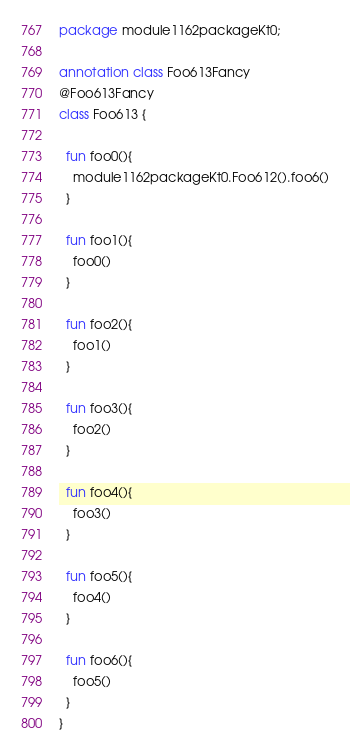Convert code to text. <code><loc_0><loc_0><loc_500><loc_500><_Kotlin_>package module1162packageKt0;

annotation class Foo613Fancy
@Foo613Fancy
class Foo613 {

  fun foo0(){
    module1162packageKt0.Foo612().foo6()
  }

  fun foo1(){
    foo0()
  }

  fun foo2(){
    foo1()
  }

  fun foo3(){
    foo2()
  }

  fun foo4(){
    foo3()
  }

  fun foo5(){
    foo4()
  }

  fun foo6(){
    foo5()
  }
}</code> 